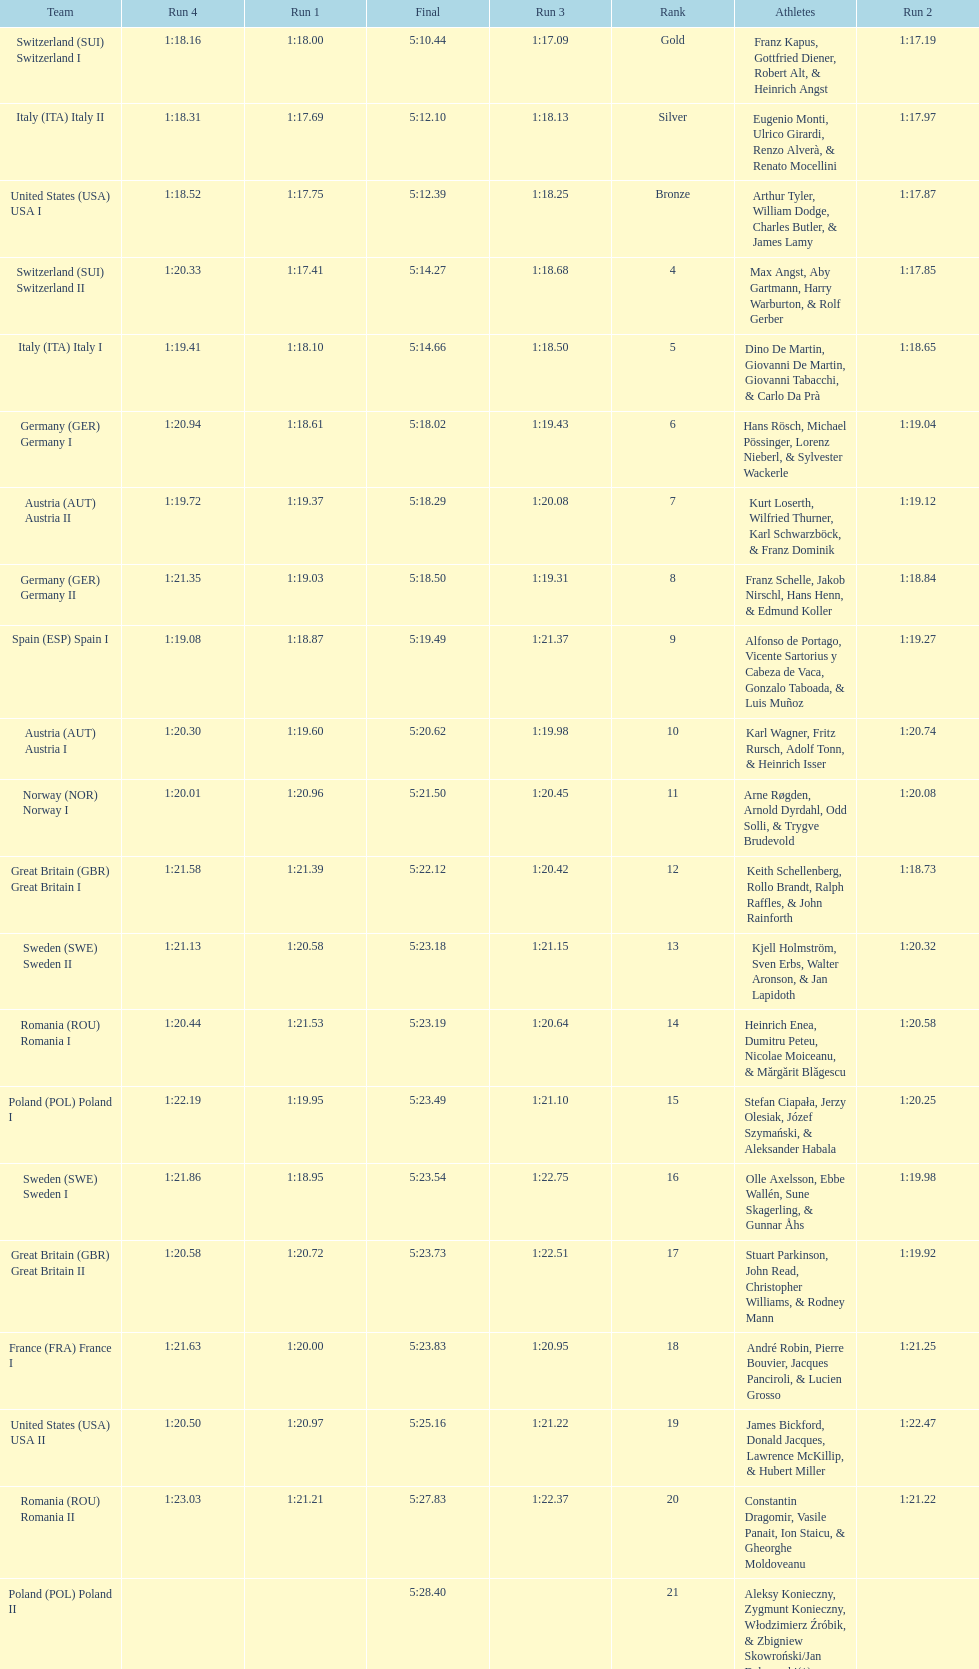Which team won the most runs? Switzerland. 